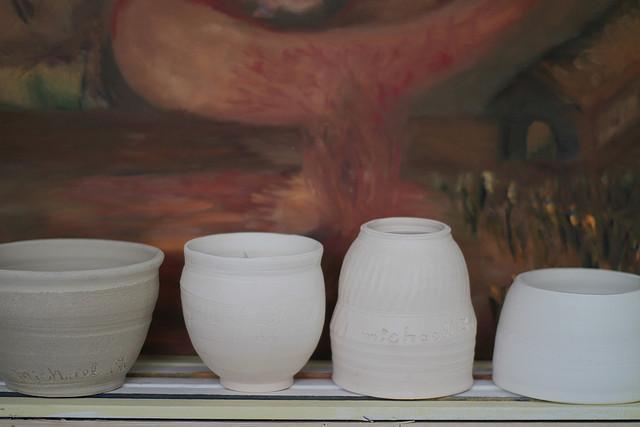How many white dishes are in this scene?
Give a very brief answer. 4. How many bowls are there?
Give a very brief answer. 4. How many cups can you see?
Give a very brief answer. 4. How many vases are there?
Give a very brief answer. 3. 